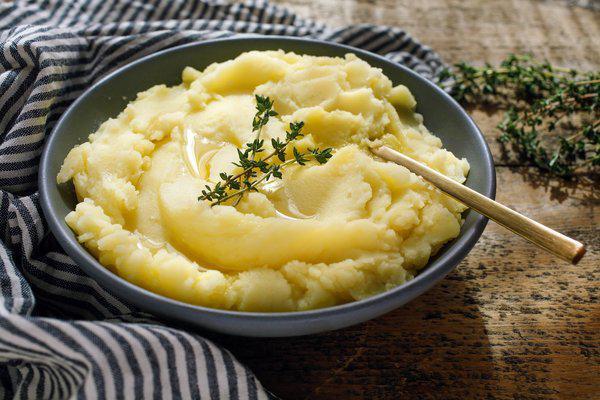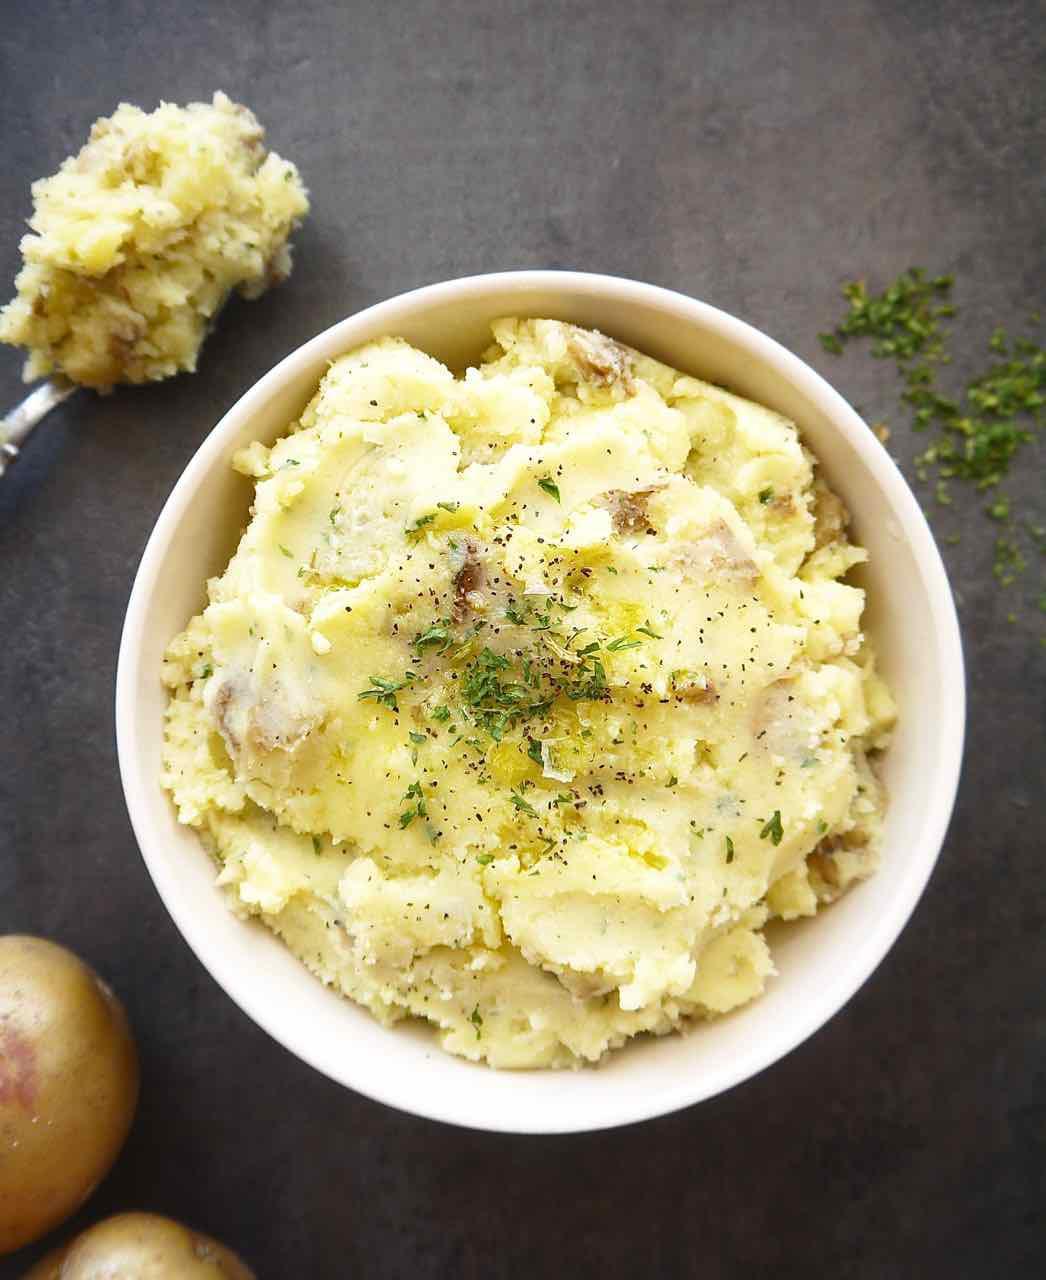The first image is the image on the left, the second image is the image on the right. Analyze the images presented: Is the assertion "Each image shows one round bowl with potatoes and some type of silver utensil in it, and one image features a white bowl with a spoon in mashed potatoes." valid? Answer yes or no. No. 